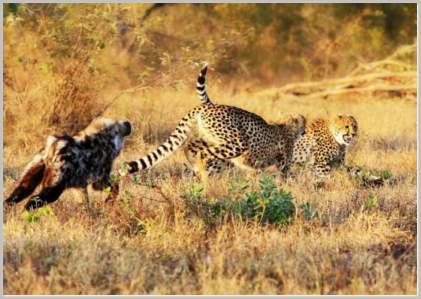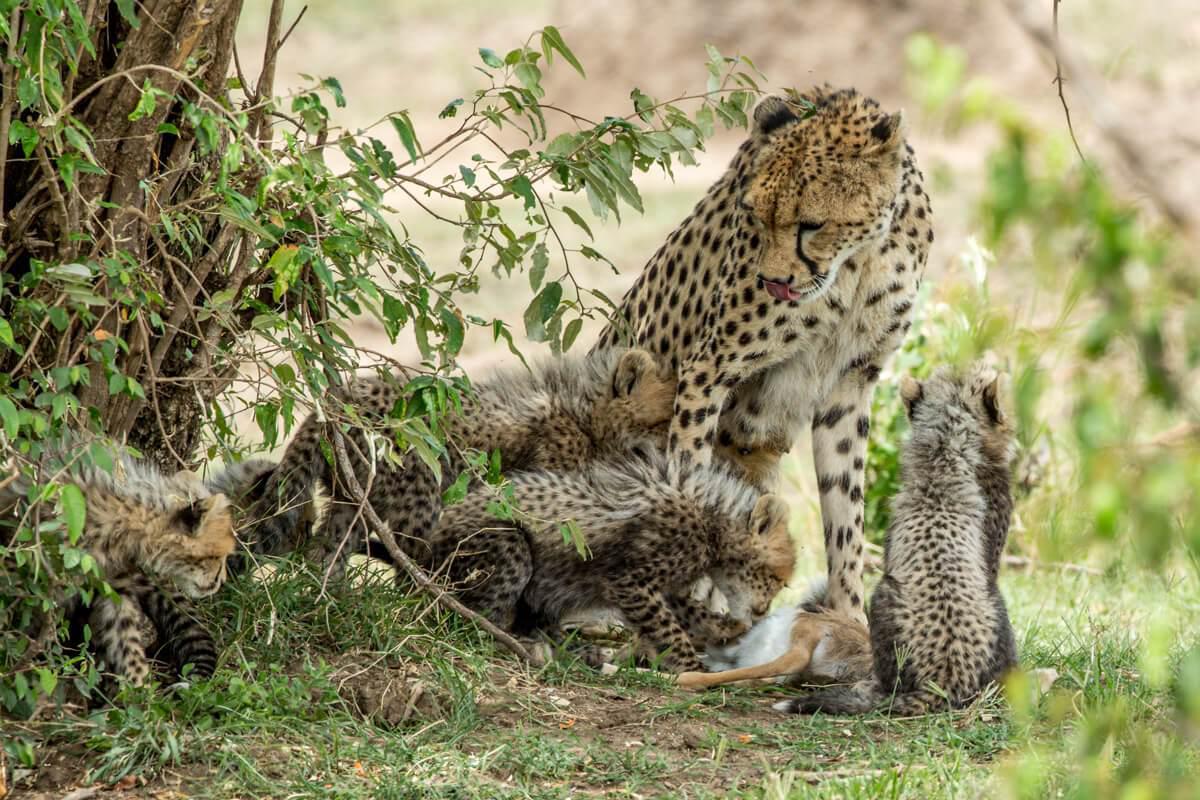The first image is the image on the left, the second image is the image on the right. Evaluate the accuracy of this statement regarding the images: "One image includes an adult cheetah with its tongue out and no prey present, and the other image shows a gazelle preyed on by at least one cheetah.". Is it true? Answer yes or no. No. The first image is the image on the left, the second image is the image on the right. Considering the images on both sides, is "In one of the images, there is at least one cheetah cub." valid? Answer yes or no. Yes. 